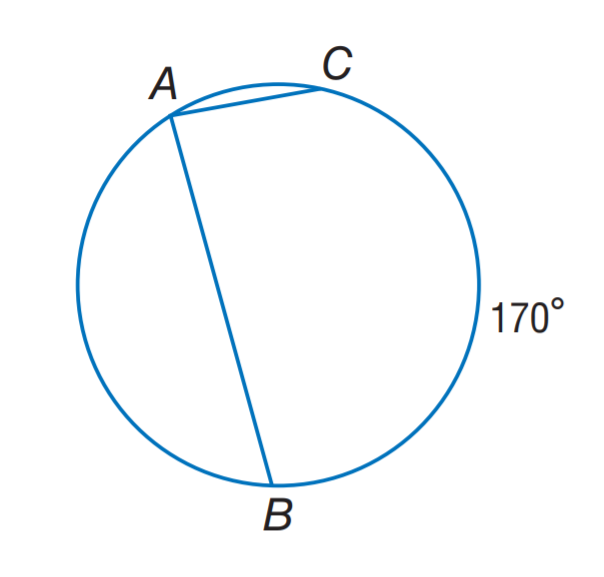Question: Find m \angle A.
Choices:
A. 42.5
B. 85
C. 95
D. 170
Answer with the letter. Answer: B 